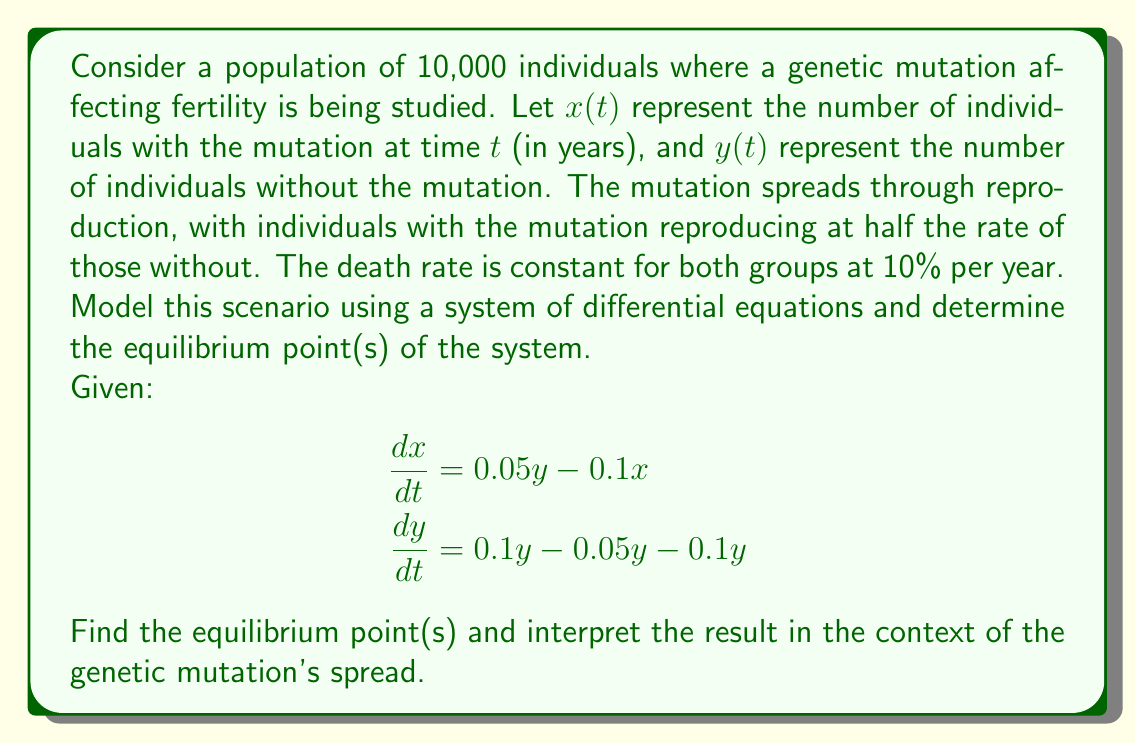Solve this math problem. To find the equilibrium point(s), we need to set both equations equal to zero and solve for x and y:

1) Set $\frac{dx}{dt} = 0$ and $\frac{dy}{dt} = 0$:

   $0 = 0.05y - 0.1x$ (Equation 1)
   $0 = 0.1y - 0.05y - 0.1y = -0.05y$ (Equation 2)

2) From Equation 2, we can see that:
   $-0.05y = 0$
   $y = 0$

3) Substituting $y = 0$ into Equation 1:
   $0 = 0.05(0) - 0.1x$
   $0 = -0.1x$
   $x = 0$

4) Therefore, the only equilibrium point is $(0, 0)$.

Interpretation:
The equilibrium point $(0, 0)$ suggests that over time, both the population with the mutation $(x)$ and without the mutation $(y)$ will approach zero. This indicates that the entire population will eventually die out.

This outcome is due to the death rate (10% per year) being higher than the maximum reproduction rate (10% per year for non-mutated individuals, 5% for mutated individuals). The mutation, which reduces fertility, exacerbates the population decline.

In the context of genetic research, this model suggests that the mutation, combined with the given demographic parameters, leads to a non-viable population. This highlights the critical impact of fertility-affecting mutations on population dynamics and emphasizes the importance of studying such genetic factors in relation to overall population health and survival.
Answer: Equilibrium point: $(0, 0)$. Population extinction. 